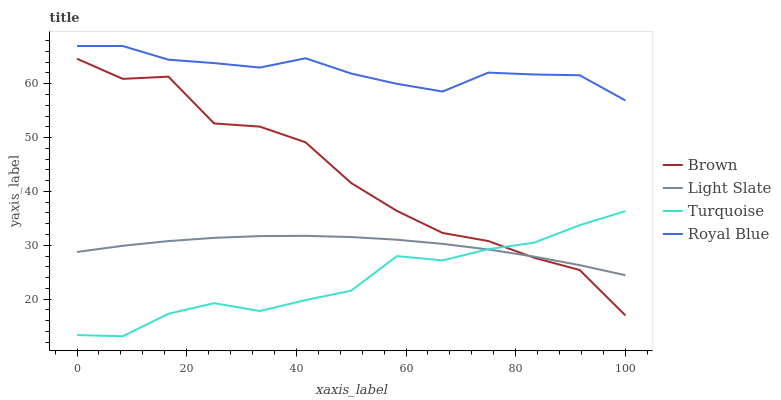Does Turquoise have the minimum area under the curve?
Answer yes or no. Yes. Does Royal Blue have the maximum area under the curve?
Answer yes or no. Yes. Does Brown have the minimum area under the curve?
Answer yes or no. No. Does Brown have the maximum area under the curve?
Answer yes or no. No. Is Light Slate the smoothest?
Answer yes or no. Yes. Is Brown the roughest?
Answer yes or no. Yes. Is Turquoise the smoothest?
Answer yes or no. No. Is Turquoise the roughest?
Answer yes or no. No. Does Turquoise have the lowest value?
Answer yes or no. Yes. Does Brown have the lowest value?
Answer yes or no. No. Does Royal Blue have the highest value?
Answer yes or no. Yes. Does Brown have the highest value?
Answer yes or no. No. Is Light Slate less than Royal Blue?
Answer yes or no. Yes. Is Royal Blue greater than Light Slate?
Answer yes or no. Yes. Does Turquoise intersect Light Slate?
Answer yes or no. Yes. Is Turquoise less than Light Slate?
Answer yes or no. No. Is Turquoise greater than Light Slate?
Answer yes or no. No. Does Light Slate intersect Royal Blue?
Answer yes or no. No. 